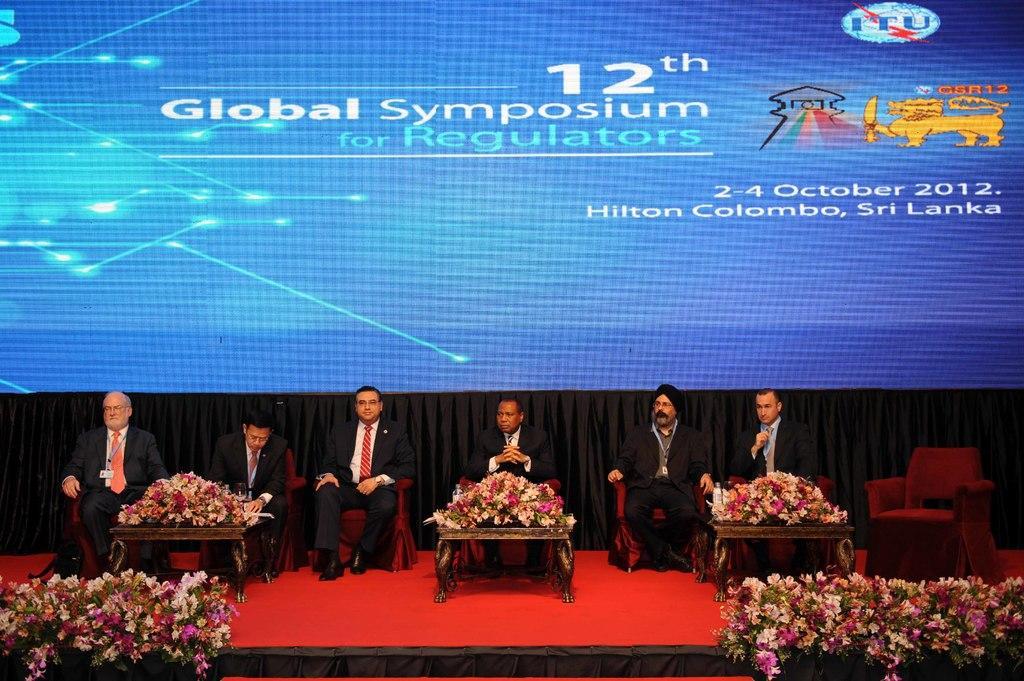Can you describe this image briefly? In this image there are a few men sitting on the chairs. In front of them there are tables. There are flowers on the tables. There is a carpet on the dais. Behind them there is a curtain. At the top there is a screen. There are numbers, text and logos displayed on the screen. At the bottom there are flowers on the dais. 